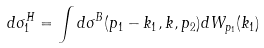Convert formula to latex. <formula><loc_0><loc_0><loc_500><loc_500>d \sigma ^ { H } _ { 1 } = \int d \sigma ^ { B } ( p _ { 1 } - k _ { 1 } , k , p _ { 2 } ) d W _ { p _ { 1 } } ( k _ { 1 } )</formula> 